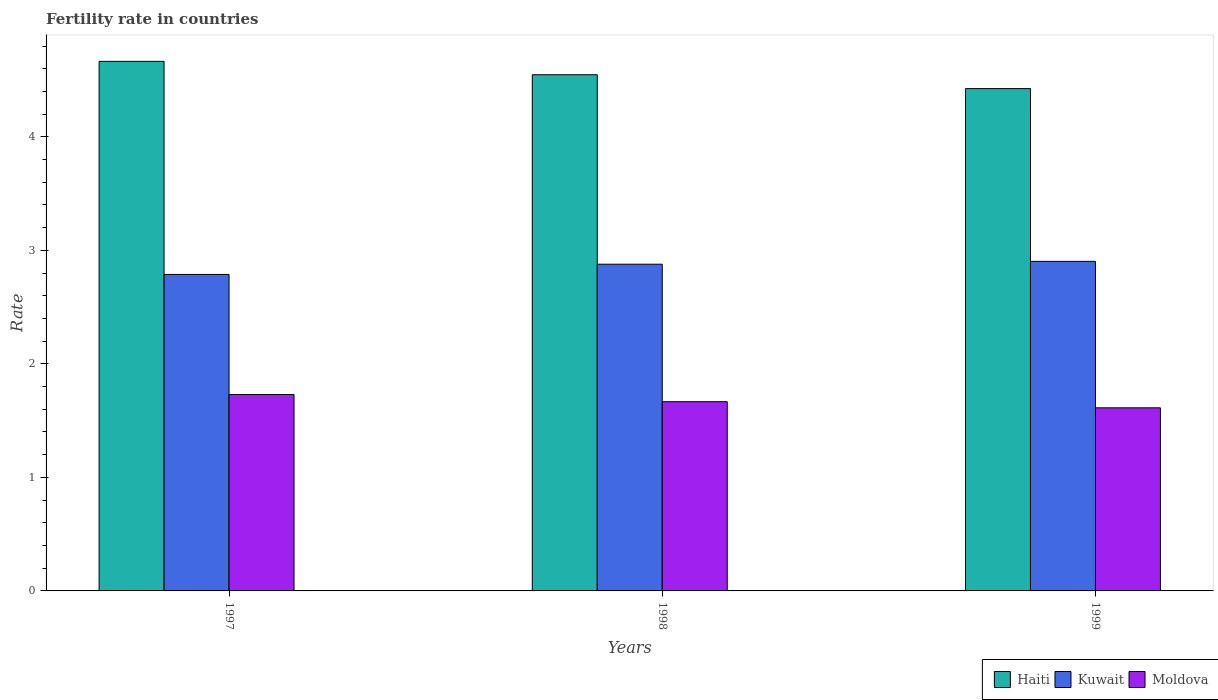How many different coloured bars are there?
Ensure brevity in your answer.  3. Are the number of bars per tick equal to the number of legend labels?
Your answer should be very brief. Yes. Are the number of bars on each tick of the X-axis equal?
Your response must be concise. Yes. How many bars are there on the 2nd tick from the right?
Your response must be concise. 3. What is the label of the 1st group of bars from the left?
Provide a succinct answer. 1997. What is the fertility rate in Moldova in 1999?
Offer a very short reply. 1.61. Across all years, what is the maximum fertility rate in Kuwait?
Give a very brief answer. 2.9. Across all years, what is the minimum fertility rate in Moldova?
Provide a short and direct response. 1.61. In which year was the fertility rate in Kuwait minimum?
Your answer should be compact. 1997. What is the total fertility rate in Moldova in the graph?
Make the answer very short. 5.01. What is the difference between the fertility rate in Haiti in 1997 and that in 1998?
Ensure brevity in your answer.  0.12. What is the difference between the fertility rate in Moldova in 1997 and the fertility rate in Kuwait in 1999?
Make the answer very short. -1.17. What is the average fertility rate in Haiti per year?
Make the answer very short. 4.55. In the year 1997, what is the difference between the fertility rate in Kuwait and fertility rate in Moldova?
Provide a short and direct response. 1.06. In how many years, is the fertility rate in Moldova greater than 2.2?
Your answer should be very brief. 0. What is the ratio of the fertility rate in Haiti in 1997 to that in 1998?
Keep it short and to the point. 1.03. Is the fertility rate in Moldova in 1997 less than that in 1998?
Give a very brief answer. No. What is the difference between the highest and the second highest fertility rate in Moldova?
Provide a succinct answer. 0.06. What is the difference between the highest and the lowest fertility rate in Kuwait?
Your answer should be compact. 0.12. What does the 1st bar from the left in 1998 represents?
Your response must be concise. Haiti. What does the 3rd bar from the right in 1999 represents?
Provide a short and direct response. Haiti. Is it the case that in every year, the sum of the fertility rate in Kuwait and fertility rate in Moldova is greater than the fertility rate in Haiti?
Ensure brevity in your answer.  No. What is the difference between two consecutive major ticks on the Y-axis?
Your answer should be very brief. 1. Are the values on the major ticks of Y-axis written in scientific E-notation?
Your response must be concise. No. Does the graph contain grids?
Provide a succinct answer. No. How many legend labels are there?
Ensure brevity in your answer.  3. How are the legend labels stacked?
Your response must be concise. Horizontal. What is the title of the graph?
Your answer should be very brief. Fertility rate in countries. What is the label or title of the X-axis?
Provide a succinct answer. Years. What is the label or title of the Y-axis?
Provide a succinct answer. Rate. What is the Rate in Haiti in 1997?
Your answer should be very brief. 4.67. What is the Rate in Kuwait in 1997?
Make the answer very short. 2.79. What is the Rate in Moldova in 1997?
Provide a succinct answer. 1.73. What is the Rate of Haiti in 1998?
Offer a very short reply. 4.55. What is the Rate in Kuwait in 1998?
Give a very brief answer. 2.88. What is the Rate of Moldova in 1998?
Provide a succinct answer. 1.67. What is the Rate in Haiti in 1999?
Your answer should be compact. 4.42. What is the Rate in Kuwait in 1999?
Your answer should be compact. 2.9. What is the Rate in Moldova in 1999?
Your answer should be very brief. 1.61. Across all years, what is the maximum Rate in Haiti?
Your response must be concise. 4.67. Across all years, what is the maximum Rate in Kuwait?
Your response must be concise. 2.9. Across all years, what is the maximum Rate in Moldova?
Provide a short and direct response. 1.73. Across all years, what is the minimum Rate of Haiti?
Your answer should be compact. 4.42. Across all years, what is the minimum Rate of Kuwait?
Ensure brevity in your answer.  2.79. Across all years, what is the minimum Rate of Moldova?
Your response must be concise. 1.61. What is the total Rate of Haiti in the graph?
Make the answer very short. 13.64. What is the total Rate in Kuwait in the graph?
Provide a short and direct response. 8.57. What is the total Rate of Moldova in the graph?
Provide a succinct answer. 5.01. What is the difference between the Rate of Haiti in 1997 and that in 1998?
Provide a short and direct response. 0.12. What is the difference between the Rate in Kuwait in 1997 and that in 1998?
Your answer should be compact. -0.09. What is the difference between the Rate of Moldova in 1997 and that in 1998?
Ensure brevity in your answer.  0.06. What is the difference between the Rate of Haiti in 1997 and that in 1999?
Make the answer very short. 0.24. What is the difference between the Rate in Kuwait in 1997 and that in 1999?
Provide a short and direct response. -0.12. What is the difference between the Rate in Moldova in 1997 and that in 1999?
Ensure brevity in your answer.  0.12. What is the difference between the Rate of Haiti in 1998 and that in 1999?
Your answer should be compact. 0.12. What is the difference between the Rate in Kuwait in 1998 and that in 1999?
Keep it short and to the point. -0.03. What is the difference between the Rate in Moldova in 1998 and that in 1999?
Your answer should be very brief. 0.05. What is the difference between the Rate in Haiti in 1997 and the Rate in Kuwait in 1998?
Provide a short and direct response. 1.79. What is the difference between the Rate of Haiti in 1997 and the Rate of Moldova in 1998?
Your answer should be very brief. 3. What is the difference between the Rate in Kuwait in 1997 and the Rate in Moldova in 1998?
Make the answer very short. 1.12. What is the difference between the Rate in Haiti in 1997 and the Rate in Kuwait in 1999?
Offer a terse response. 1.76. What is the difference between the Rate in Haiti in 1997 and the Rate in Moldova in 1999?
Your answer should be compact. 3.05. What is the difference between the Rate in Kuwait in 1997 and the Rate in Moldova in 1999?
Provide a succinct answer. 1.18. What is the difference between the Rate in Haiti in 1998 and the Rate in Kuwait in 1999?
Keep it short and to the point. 1.64. What is the difference between the Rate in Haiti in 1998 and the Rate in Moldova in 1999?
Your answer should be very brief. 2.93. What is the difference between the Rate of Kuwait in 1998 and the Rate of Moldova in 1999?
Ensure brevity in your answer.  1.26. What is the average Rate in Haiti per year?
Provide a short and direct response. 4.55. What is the average Rate of Kuwait per year?
Keep it short and to the point. 2.86. What is the average Rate of Moldova per year?
Your response must be concise. 1.67. In the year 1997, what is the difference between the Rate of Haiti and Rate of Kuwait?
Keep it short and to the point. 1.88. In the year 1997, what is the difference between the Rate in Haiti and Rate in Moldova?
Make the answer very short. 2.94. In the year 1997, what is the difference between the Rate in Kuwait and Rate in Moldova?
Offer a very short reply. 1.06. In the year 1998, what is the difference between the Rate of Haiti and Rate of Kuwait?
Provide a short and direct response. 1.67. In the year 1998, what is the difference between the Rate in Haiti and Rate in Moldova?
Your response must be concise. 2.88. In the year 1998, what is the difference between the Rate in Kuwait and Rate in Moldova?
Ensure brevity in your answer.  1.21. In the year 1999, what is the difference between the Rate of Haiti and Rate of Kuwait?
Provide a short and direct response. 1.52. In the year 1999, what is the difference between the Rate in Haiti and Rate in Moldova?
Give a very brief answer. 2.81. In the year 1999, what is the difference between the Rate in Kuwait and Rate in Moldova?
Offer a very short reply. 1.29. What is the ratio of the Rate of Kuwait in 1997 to that in 1998?
Your answer should be compact. 0.97. What is the ratio of the Rate in Moldova in 1997 to that in 1998?
Provide a succinct answer. 1.04. What is the ratio of the Rate in Haiti in 1997 to that in 1999?
Provide a short and direct response. 1.05. What is the ratio of the Rate in Kuwait in 1997 to that in 1999?
Offer a terse response. 0.96. What is the ratio of the Rate in Moldova in 1997 to that in 1999?
Your answer should be very brief. 1.07. What is the ratio of the Rate of Haiti in 1998 to that in 1999?
Provide a short and direct response. 1.03. What is the ratio of the Rate of Moldova in 1998 to that in 1999?
Your response must be concise. 1.03. What is the difference between the highest and the second highest Rate of Haiti?
Your answer should be compact. 0.12. What is the difference between the highest and the second highest Rate of Kuwait?
Provide a short and direct response. 0.03. What is the difference between the highest and the second highest Rate of Moldova?
Offer a very short reply. 0.06. What is the difference between the highest and the lowest Rate in Haiti?
Offer a terse response. 0.24. What is the difference between the highest and the lowest Rate of Kuwait?
Offer a terse response. 0.12. What is the difference between the highest and the lowest Rate in Moldova?
Keep it short and to the point. 0.12. 